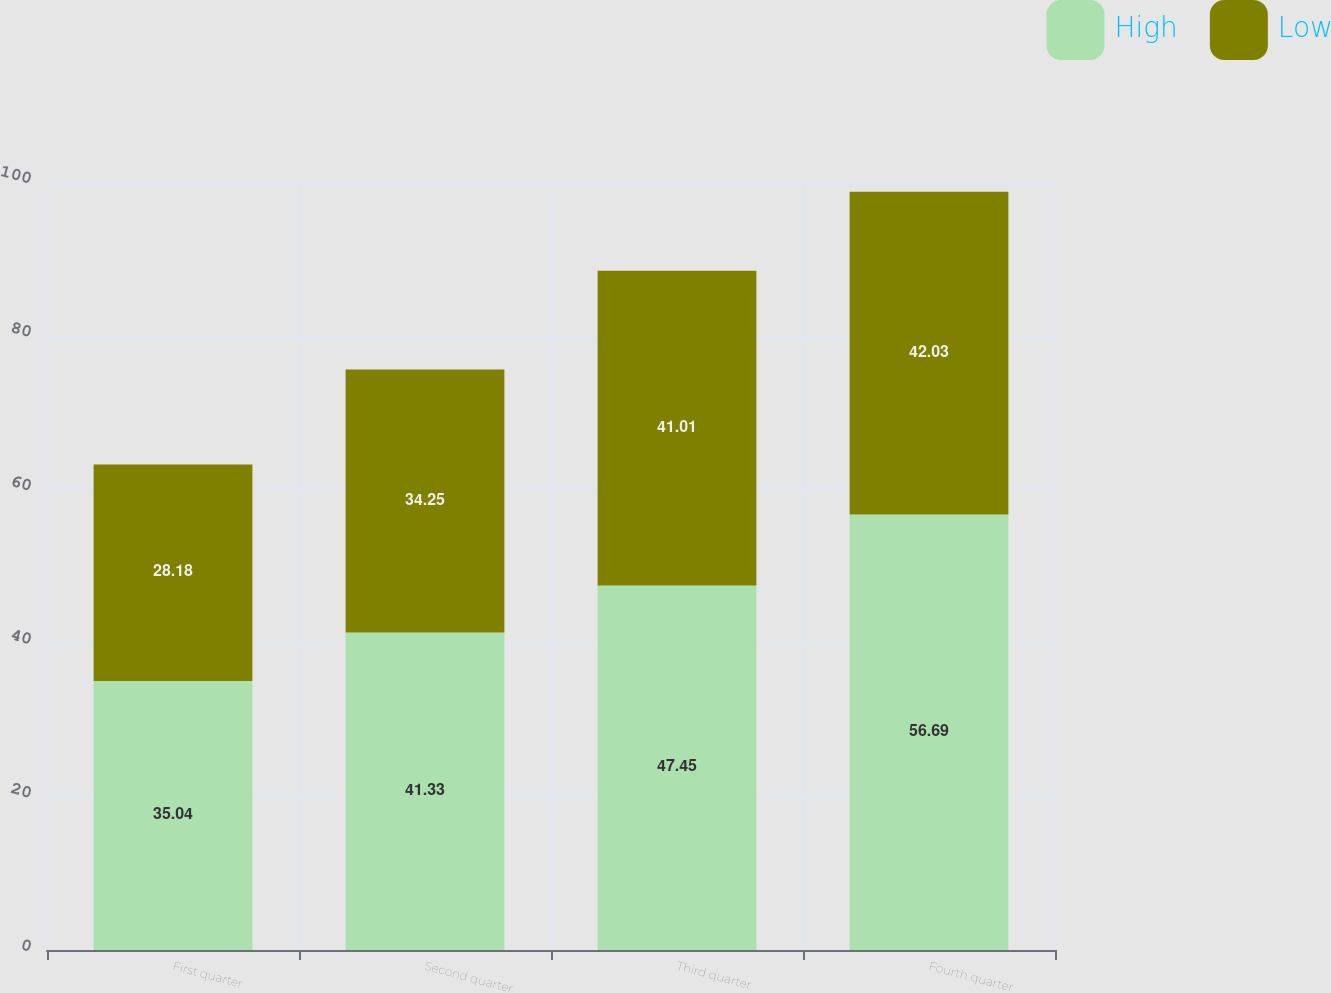<chart> <loc_0><loc_0><loc_500><loc_500><stacked_bar_chart><ecel><fcel>First quarter<fcel>Second quarter<fcel>Third quarter<fcel>Fourth quarter<nl><fcel>High<fcel>35.04<fcel>41.33<fcel>47.45<fcel>56.69<nl><fcel>Low<fcel>28.18<fcel>34.25<fcel>41.01<fcel>42.03<nl></chart> 